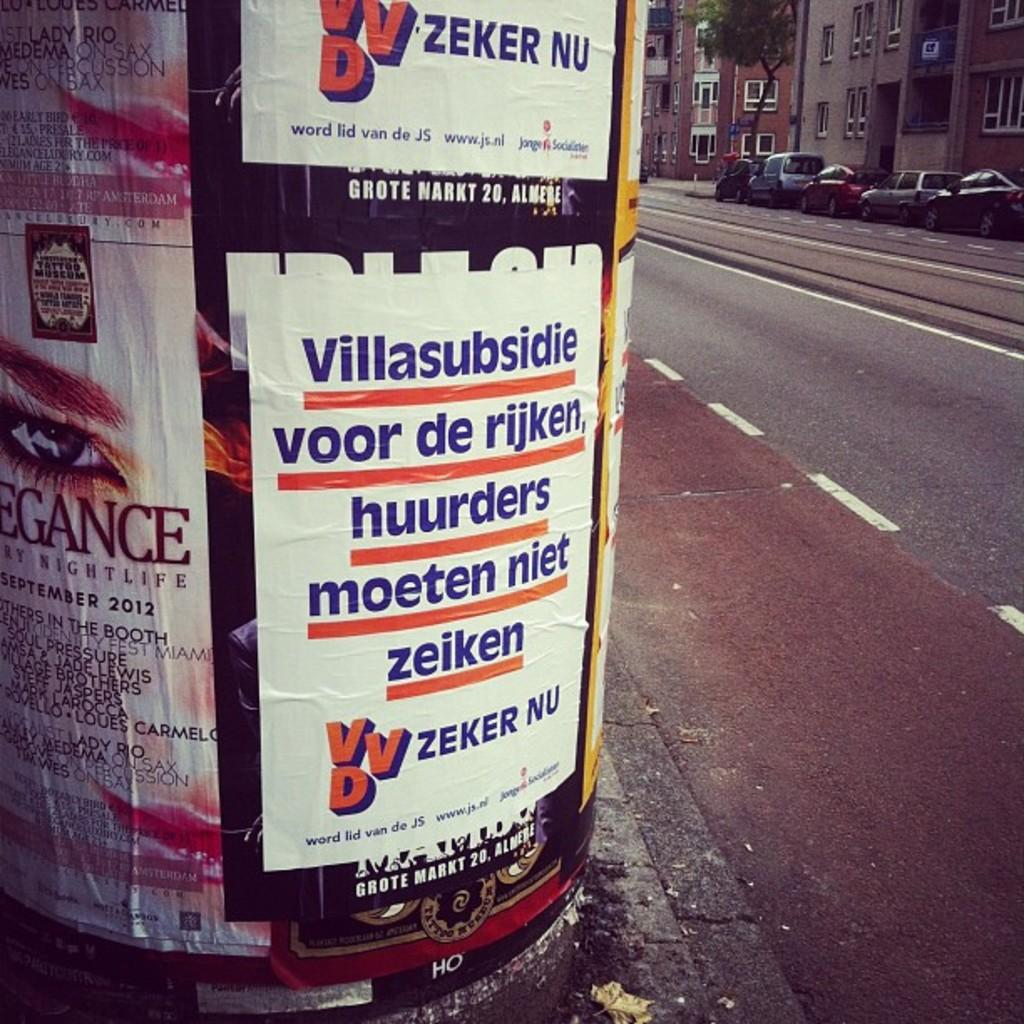Provide a one-sentence caption for the provided image. Posters with VVD logo for Zeker Nu on a big pole. 